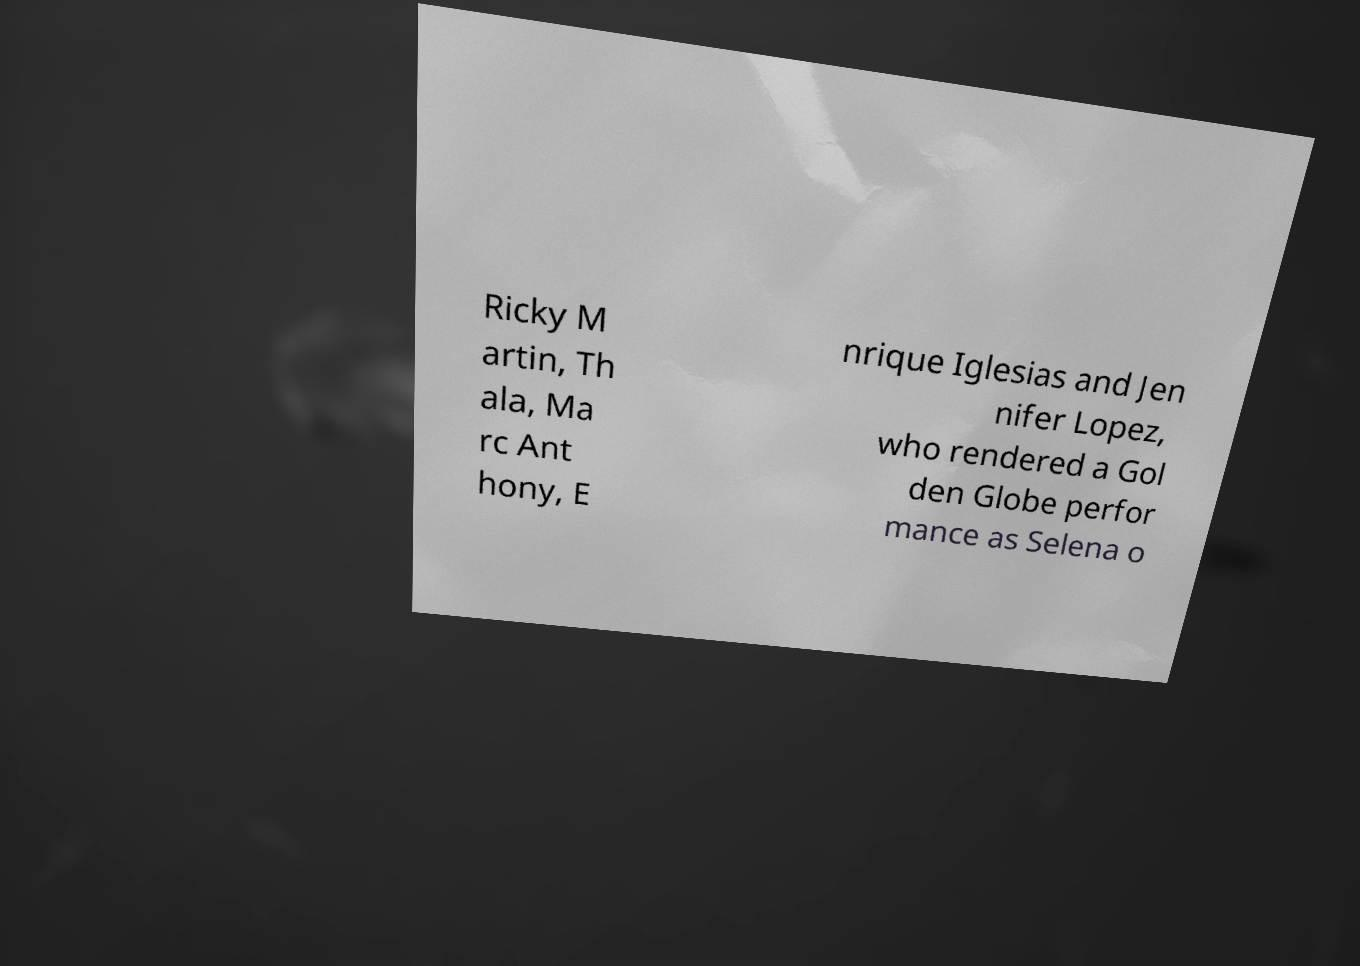What messages or text are displayed in this image? I need them in a readable, typed format. Ricky M artin, Th ala, Ma rc Ant hony, E nrique Iglesias and Jen nifer Lopez, who rendered a Gol den Globe perfor mance as Selena o 